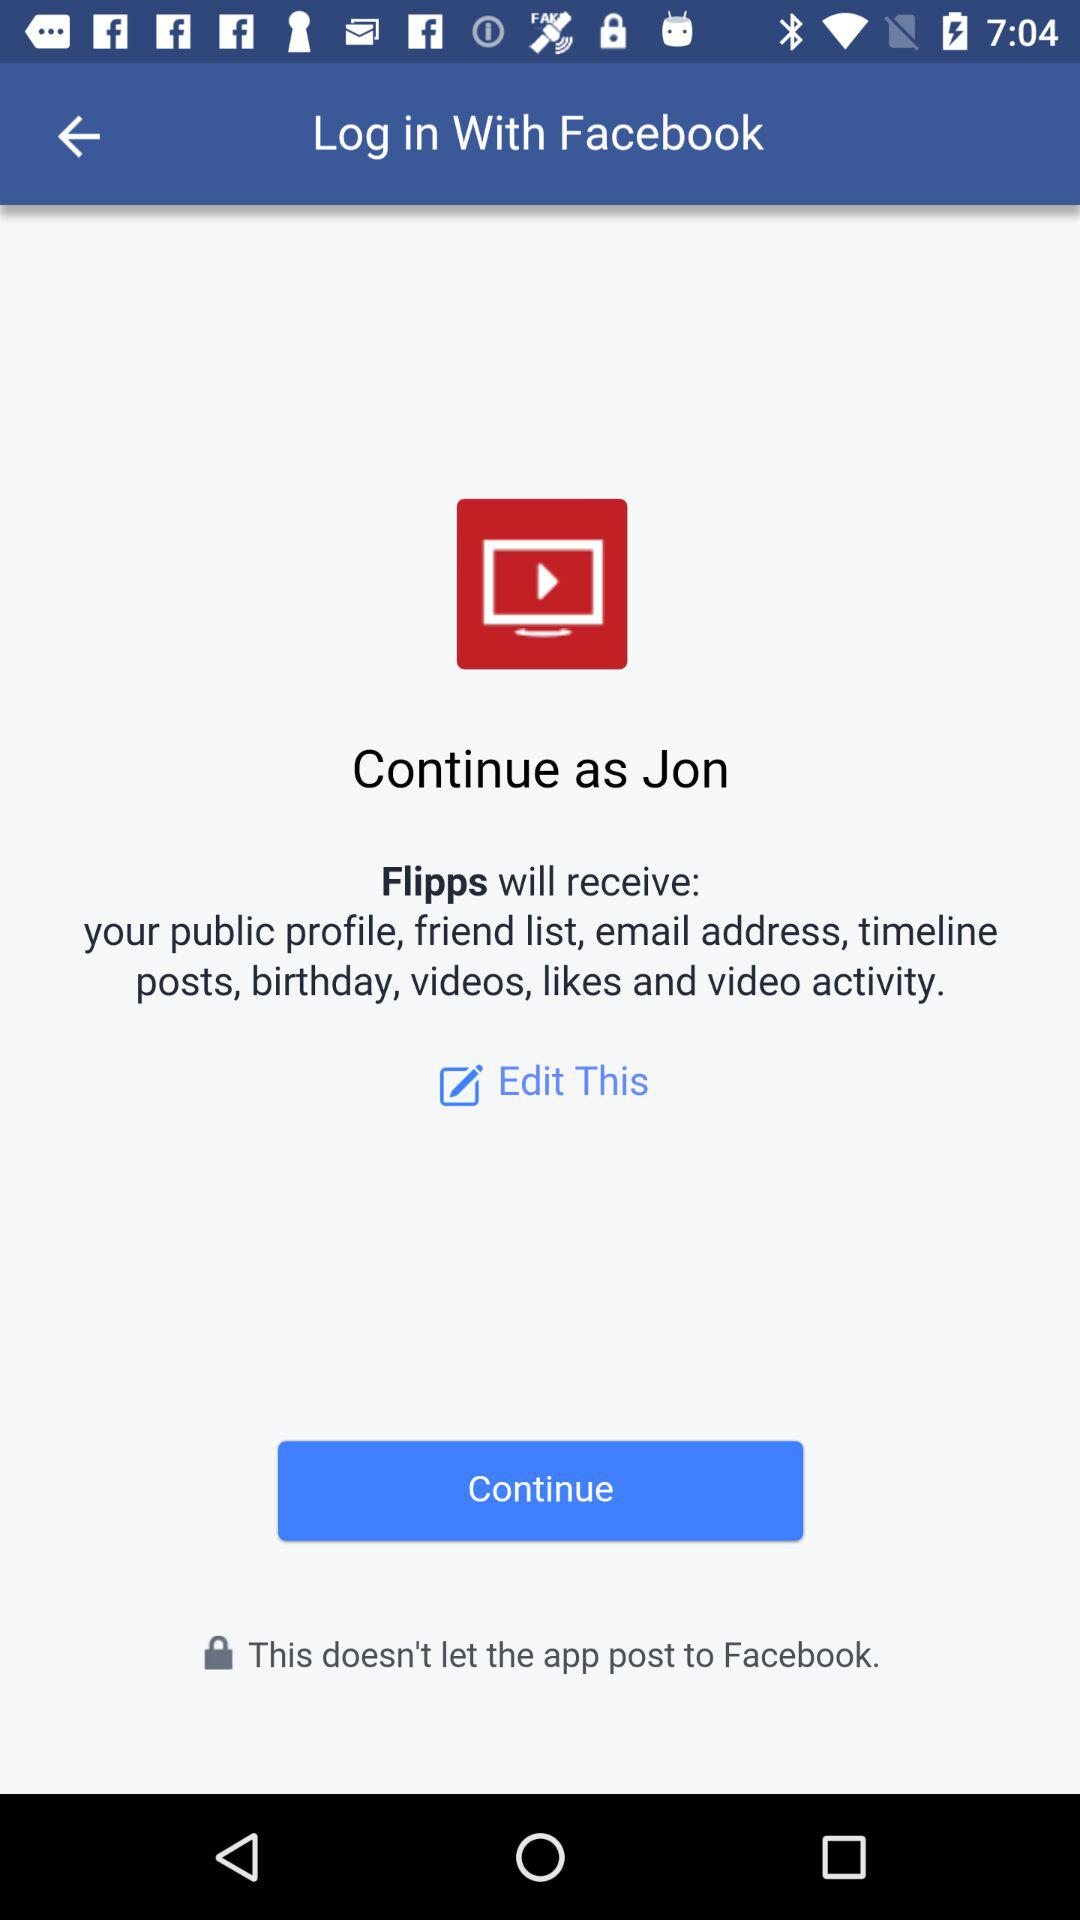What application is asking for permission?
Answer the question using a single word or phrase. The application is "Flipps" 